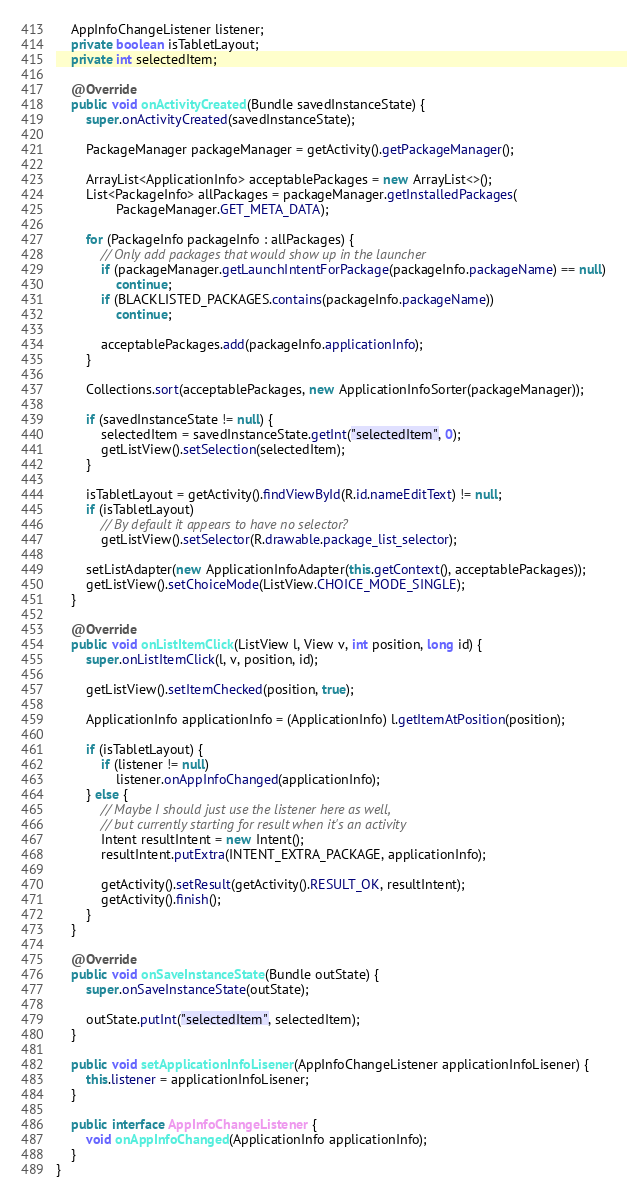Convert code to text. <code><loc_0><loc_0><loc_500><loc_500><_Java_>
    AppInfoChangeListener listener;
    private boolean isTabletLayout;
    private int selectedItem;

    @Override
    public void onActivityCreated(Bundle savedInstanceState) {
        super.onActivityCreated(savedInstanceState);

        PackageManager packageManager = getActivity().getPackageManager();

        ArrayList<ApplicationInfo> acceptablePackages = new ArrayList<>();
        List<PackageInfo> allPackages = packageManager.getInstalledPackages(
                PackageManager.GET_META_DATA);

        for (PackageInfo packageInfo : allPackages) {
            // Only add packages that would show up in the launcher
            if (packageManager.getLaunchIntentForPackage(packageInfo.packageName) == null)
                continue;
            if (BLACKLISTED_PACKAGES.contains(packageInfo.packageName))
                continue;

            acceptablePackages.add(packageInfo.applicationInfo);
        }

        Collections.sort(acceptablePackages, new ApplicationInfoSorter(packageManager));

        if (savedInstanceState != null) {
            selectedItem = savedInstanceState.getInt("selectedItem", 0);
            getListView().setSelection(selectedItem);
        }

        isTabletLayout = getActivity().findViewById(R.id.nameEditText) != null;
        if (isTabletLayout)
            // By default it appears to have no selector?
            getListView().setSelector(R.drawable.package_list_selector);

        setListAdapter(new ApplicationInfoAdapter(this.getContext(), acceptablePackages));
        getListView().setChoiceMode(ListView.CHOICE_MODE_SINGLE);
    }

    @Override
    public void onListItemClick(ListView l, View v, int position, long id) {
        super.onListItemClick(l, v, position, id);

        getListView().setItemChecked(position, true);

        ApplicationInfo applicationInfo = (ApplicationInfo) l.getItemAtPosition(position);

        if (isTabletLayout) {
            if (listener != null)
                listener.onAppInfoChanged(applicationInfo);
        } else {
            // Maybe I should just use the listener here as well,
            // but currently starting for result when it's an activity
            Intent resultIntent = new Intent();
            resultIntent.putExtra(INTENT_EXTRA_PACKAGE, applicationInfo);

            getActivity().setResult(getActivity().RESULT_OK, resultIntent);
            getActivity().finish();
        }
    }

    @Override
    public void onSaveInstanceState(Bundle outState) {
        super.onSaveInstanceState(outState);

        outState.putInt("selectedItem", selectedItem);
    }

    public void setApplicationInfoLisener(AppInfoChangeListener applicationInfoLisener) {
        this.listener = applicationInfoLisener;
    }

    public interface AppInfoChangeListener {
        void onAppInfoChanged(ApplicationInfo applicationInfo);
    }
}
</code> 